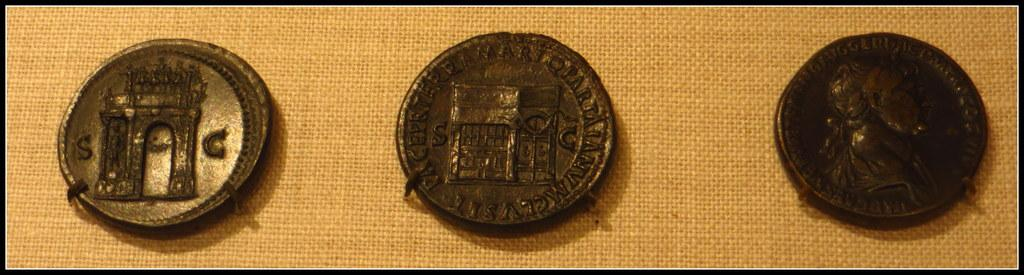How many coins are visible in the image? There are three coins in the image. What colors are the coins? The coins are black and brown in color. What is the color of the background in the image? The background of the image is brown. What type of prison can be seen in the image? There is no prison present in the image; it only features three coins. How many coils are visible in the image? There are no coils present in the image; it only features three coins. 